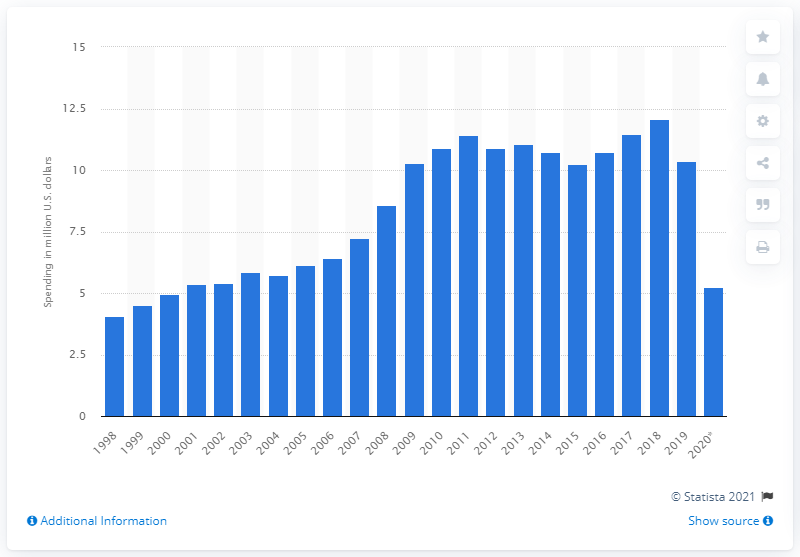Outline some significant characteristics in this image. As of June 2020, General Dynamics had spent a total of $5,240,000 on lobbying. General Dynamics spent $10,350,000 on lobbying in 2019. 